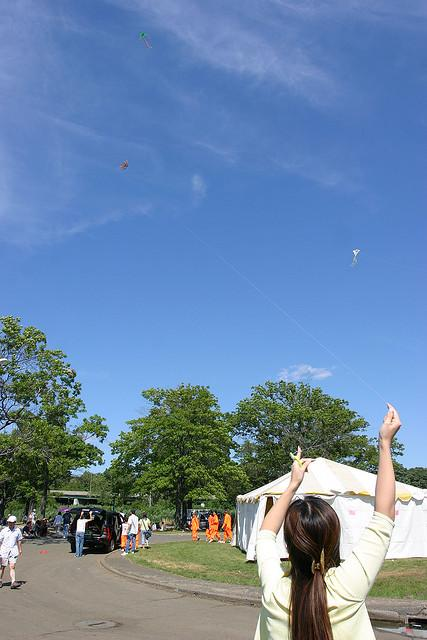What makes this a good day for flying kites? Please explain your reasoning. clear skies. The skies are blue and without clouds. 